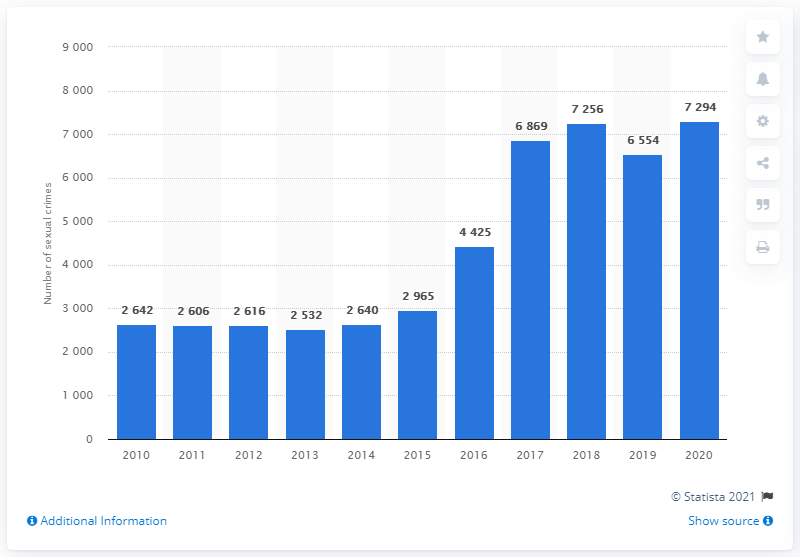Can we deduce any patterns about the frequency of sexual crimes during this ten-year span? While the image indicates fluctuations in the reported numbers, a distinct pattern is not immediately apparent without further context or data. However, the overall trajectory points to an increase, especially noticeable between 2016 and 2020. Further analysis would be necessary to determine any specific patterns or causes for the fluctuations. 